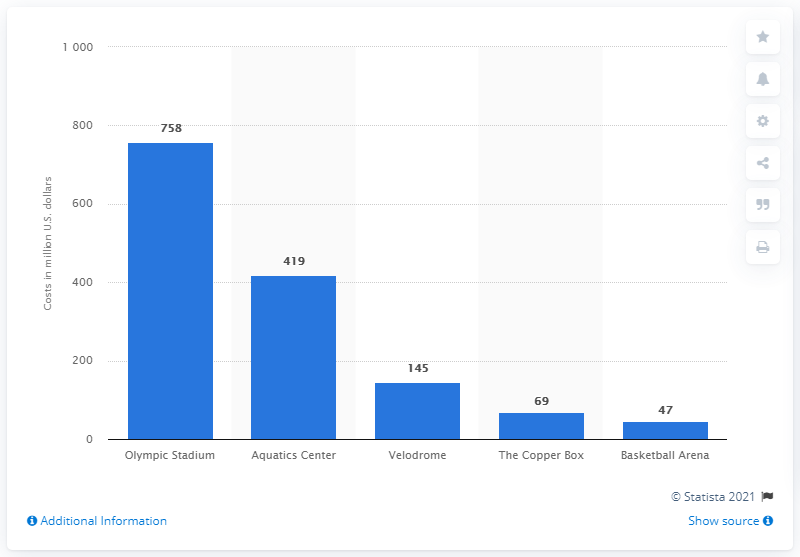Can you rank all the facilities based on the cost from highest to lowest? Here's the ranking based on cost from highest to lowest: Olympic Stadium (758 million), Aquatics Center (419 million), Velodrome (145 million), The Copper Box (69 million), and Basketball Arena (47 million). 